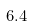<formula> <loc_0><loc_0><loc_500><loc_500>6 . 4</formula> 